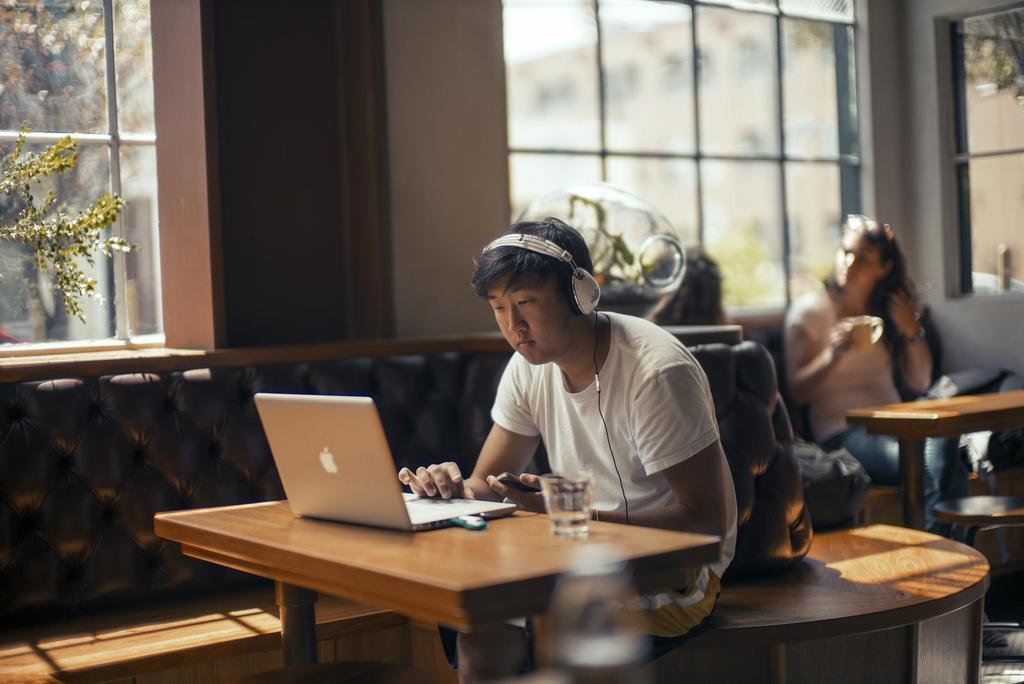In one or two sentences, can you explain what this image depicts? A man sitting in coffee shop working on his laptop,wearing headphones and holding mobile phone in his left hand. There are two women behind talking to each other. 